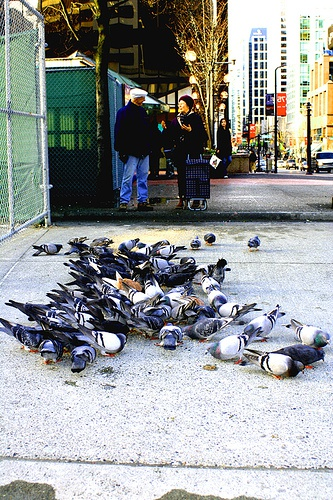Describe the objects in this image and their specific colors. I can see bird in gray, black, white, and navy tones, people in gray, black, navy, and maroon tones, people in gray, black, navy, and blue tones, suitcase in gray, black, navy, and blue tones, and bird in gray, black, and navy tones in this image. 